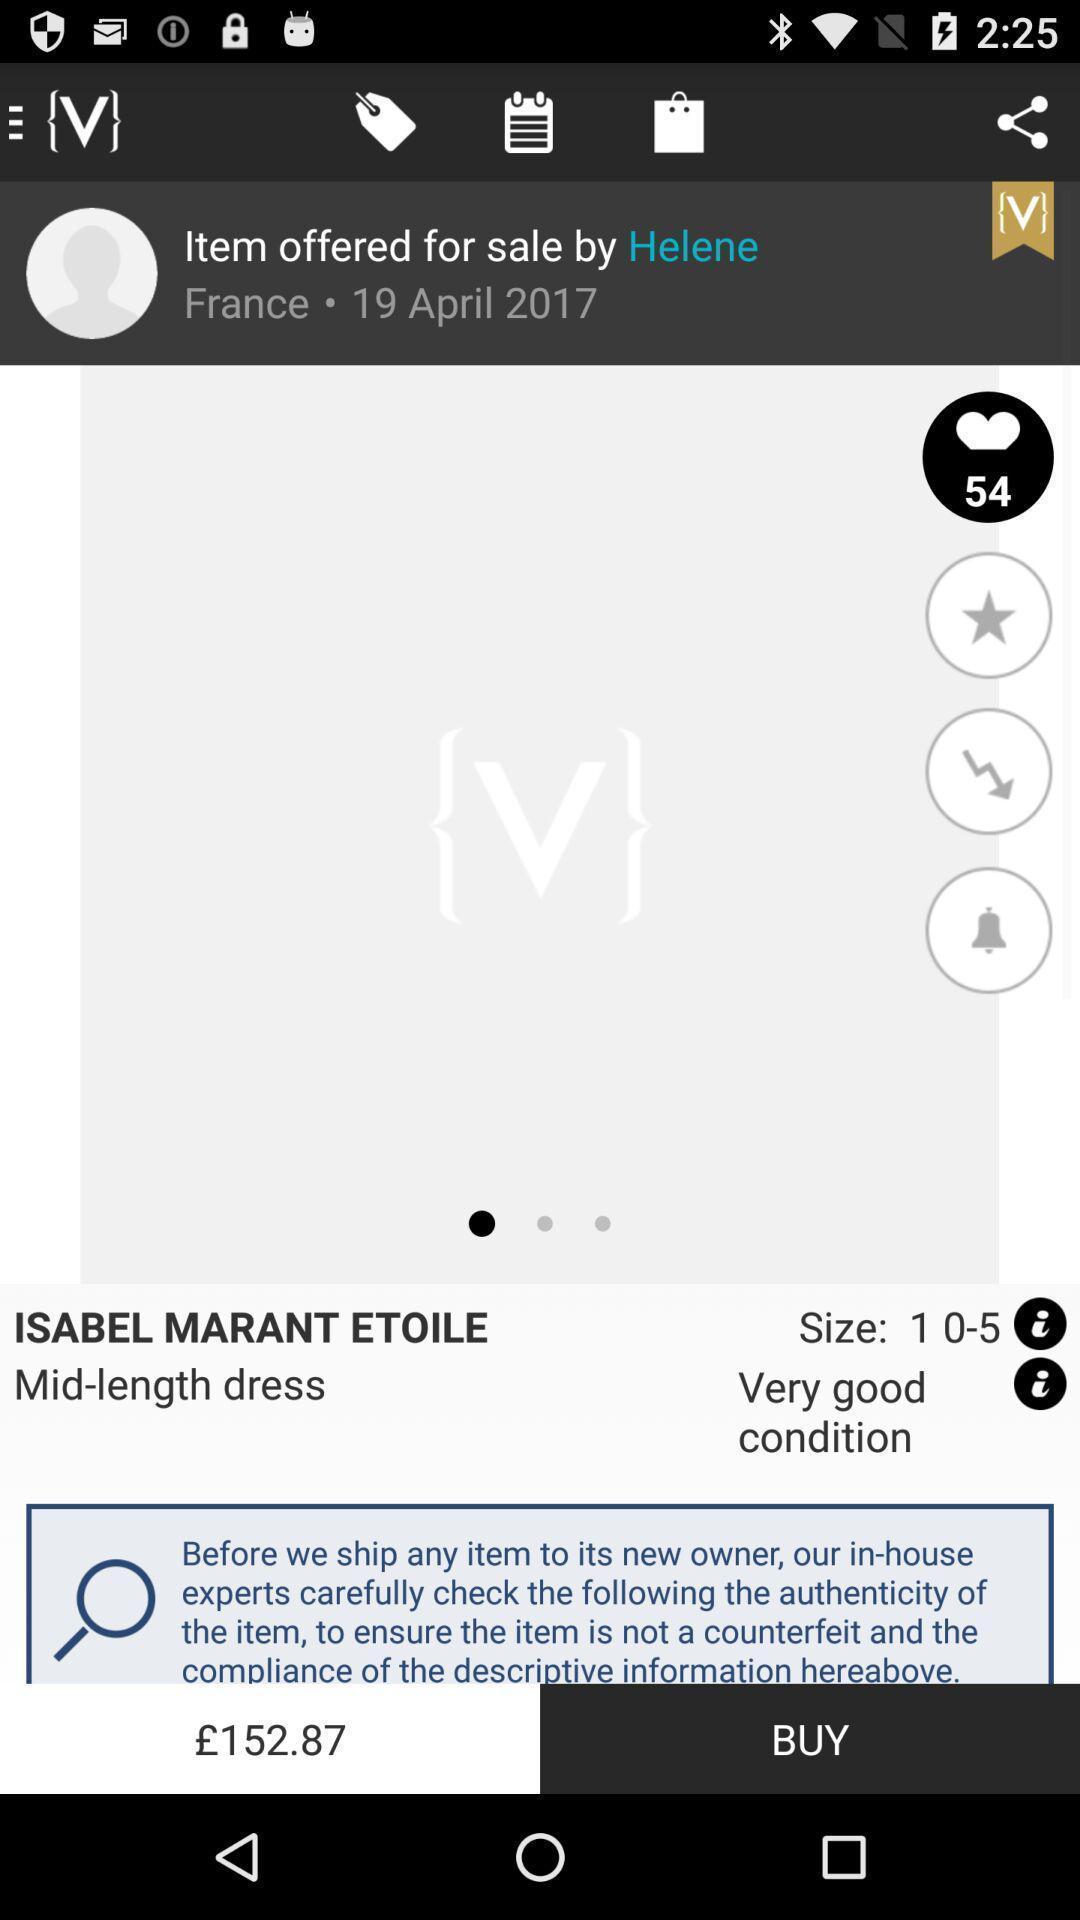Provide a detailed account of this screenshot. Screen shows about a global fashion community. 